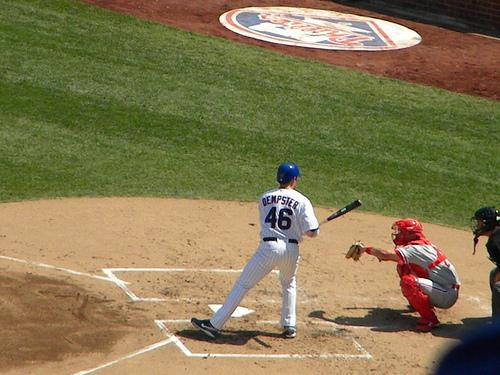What is number 46 waiting for? Please explain your reasoning. ball pitched. Number 46 wants to hit the ball. 